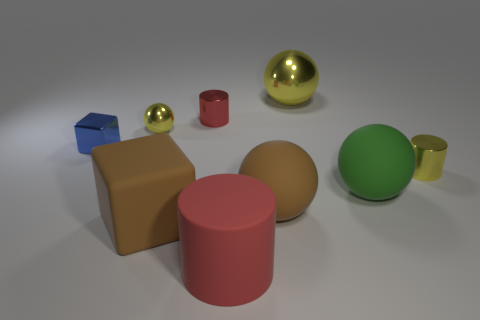Subtract all small metallic cylinders. How many cylinders are left? 1 Add 1 matte things. How many objects exist? 10 Subtract all cubes. How many objects are left? 7 Subtract all red cylinders. How many cylinders are left? 1 Subtract all yellow cubes. How many blue spheres are left? 0 Subtract all large brown shiny balls. Subtract all yellow things. How many objects are left? 6 Add 4 large brown blocks. How many large brown blocks are left? 5 Add 5 large yellow metal things. How many large yellow metal things exist? 6 Subtract 0 gray cylinders. How many objects are left? 9 Subtract 2 spheres. How many spheres are left? 2 